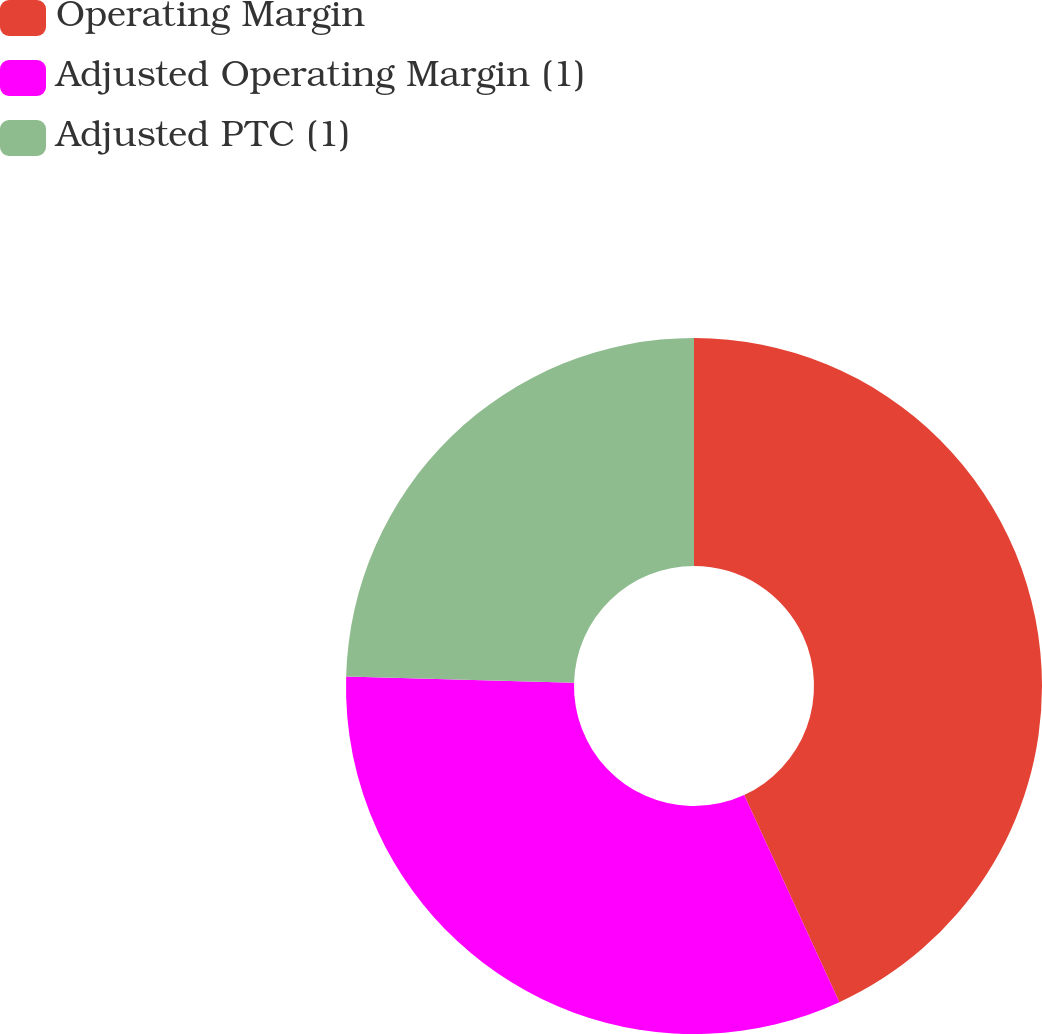<chart> <loc_0><loc_0><loc_500><loc_500><pie_chart><fcel>Operating Margin<fcel>Adjusted Operating Margin (1)<fcel>Adjusted PTC (1)<nl><fcel>43.14%<fcel>32.3%<fcel>24.56%<nl></chart> 